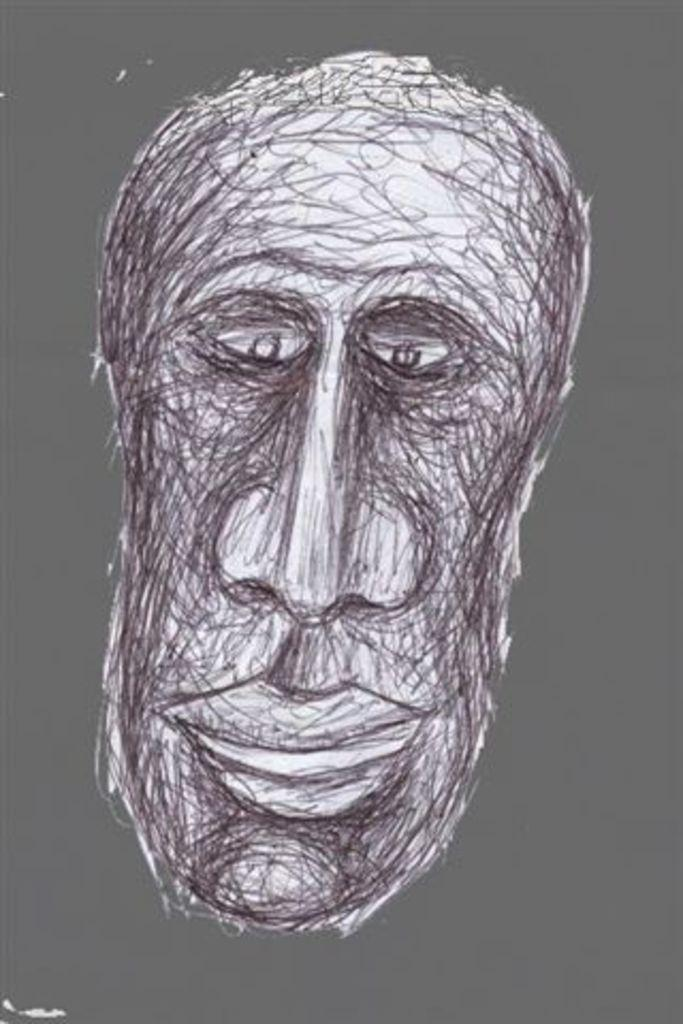What type of artwork is featured in the image? There is a pencil sketch in the image. Can you describe the style of the pencil sketch? The pencil sketch is in a cartoon style. What subject matter is depicted in the pencil sketch? The pencil sketch depicts a person's face. What type of doctor is depicted in the pencil sketch? There is no doctor depicted in the pencil sketch; it features a person's face in a cartoon style. 